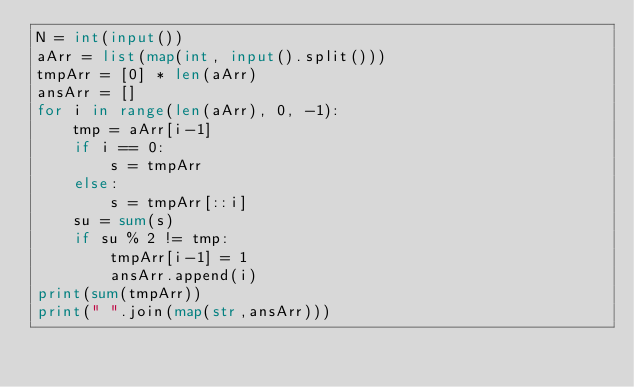<code> <loc_0><loc_0><loc_500><loc_500><_Python_>N = int(input())
aArr = list(map(int, input().split()))
tmpArr = [0] * len(aArr)
ansArr = []
for i in range(len(aArr), 0, -1):
    tmp = aArr[i-1]
    if i == 0:
        s = tmpArr
    else:
        s = tmpArr[::i]
    su = sum(s)
    if su % 2 != tmp:
        tmpArr[i-1] = 1
        ansArr.append(i)
print(sum(tmpArr))
print(" ".join(map(str,ansArr)))
</code> 